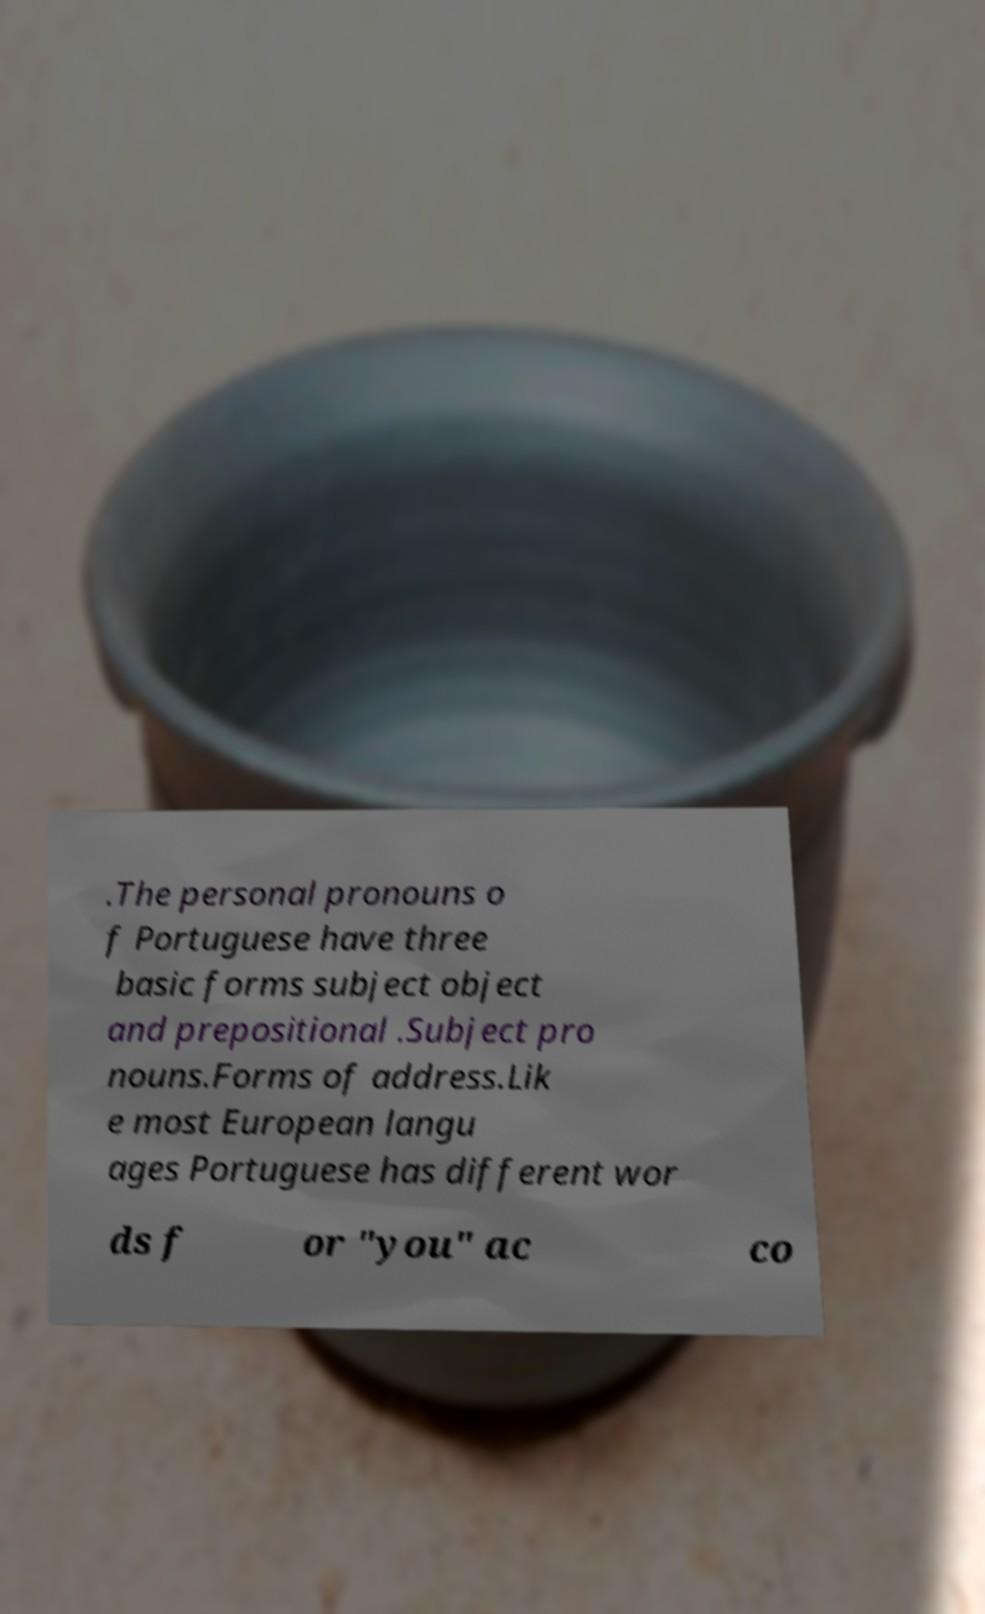Can you read and provide the text displayed in the image?This photo seems to have some interesting text. Can you extract and type it out for me? .The personal pronouns o f Portuguese have three basic forms subject object and prepositional .Subject pro nouns.Forms of address.Lik e most European langu ages Portuguese has different wor ds f or "you" ac co 